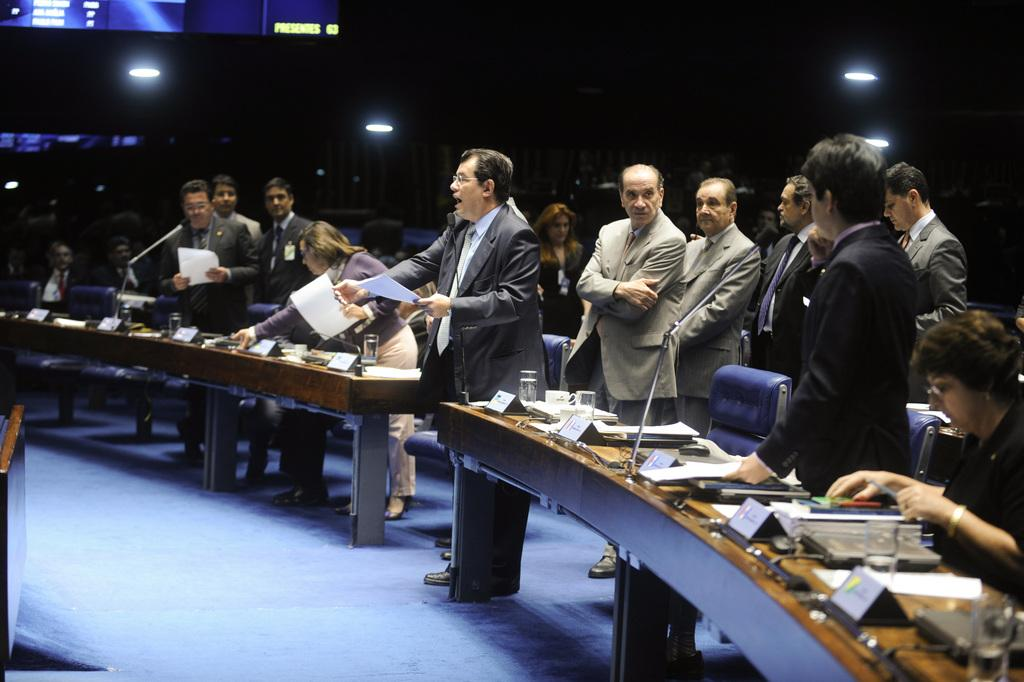How many men are present in the image? There are many men in the image. What are the men wearing in the image? The men are standing in suits. What is located behind the men in the image? The men are standing in front of a table. What items can be seen on the table in the image? The table has microphones, papers, and glasses on it. What type of room is the image taken in? The image was taken in a conference room. How many cherries are on the table in the image? There are no cherries present on the table in the image. What type of bikes can be seen in the image? There are no bikes present in the image. 